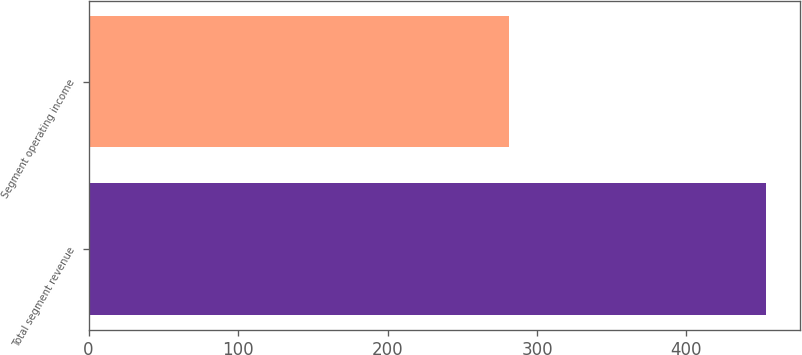Convert chart to OTSL. <chart><loc_0><loc_0><loc_500><loc_500><bar_chart><fcel>Total segment revenue<fcel>Segment operating income<nl><fcel>453<fcel>281<nl></chart> 